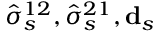Convert formula to latex. <formula><loc_0><loc_0><loc_500><loc_500>\hat { \sigma } _ { s } ^ { 1 2 } , \hat { \sigma } _ { s } ^ { 2 1 } , d _ { s }</formula> 